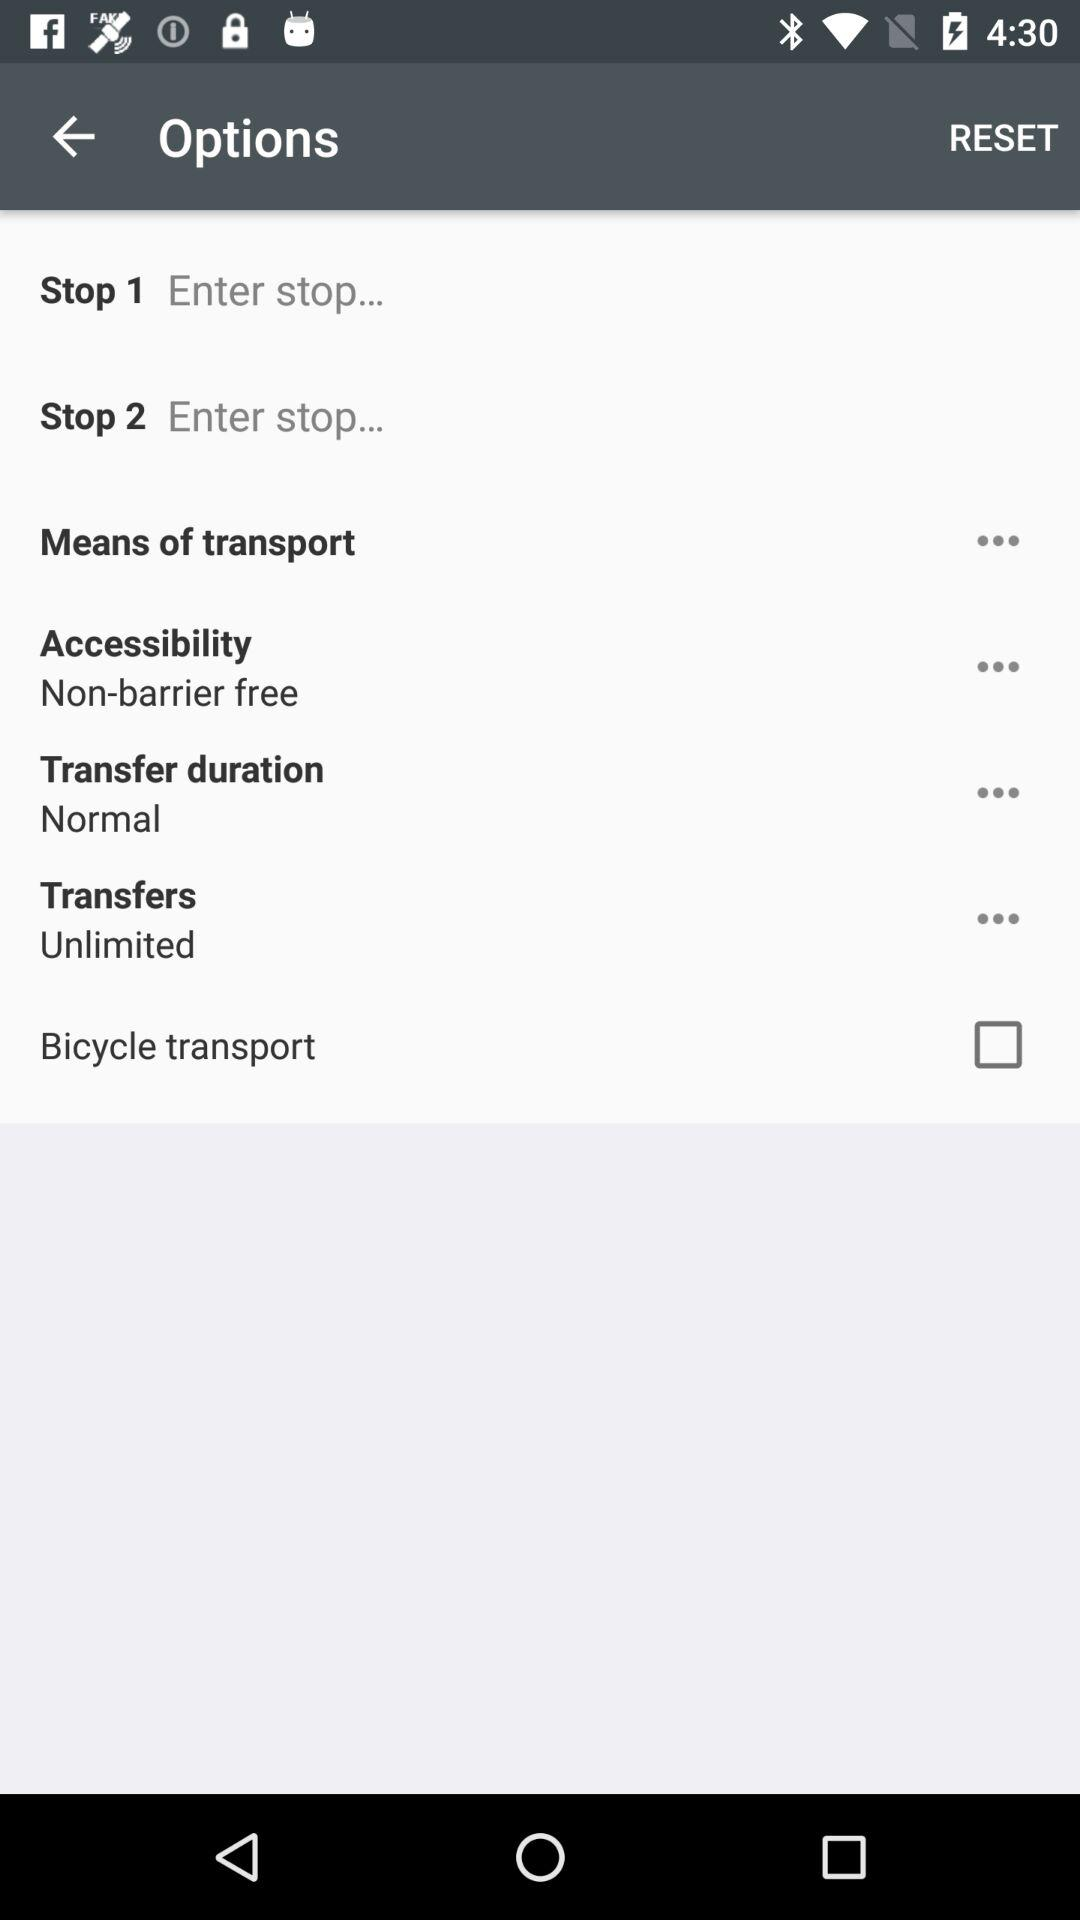What is the transfer duration? The transfer duration is "Normal". 